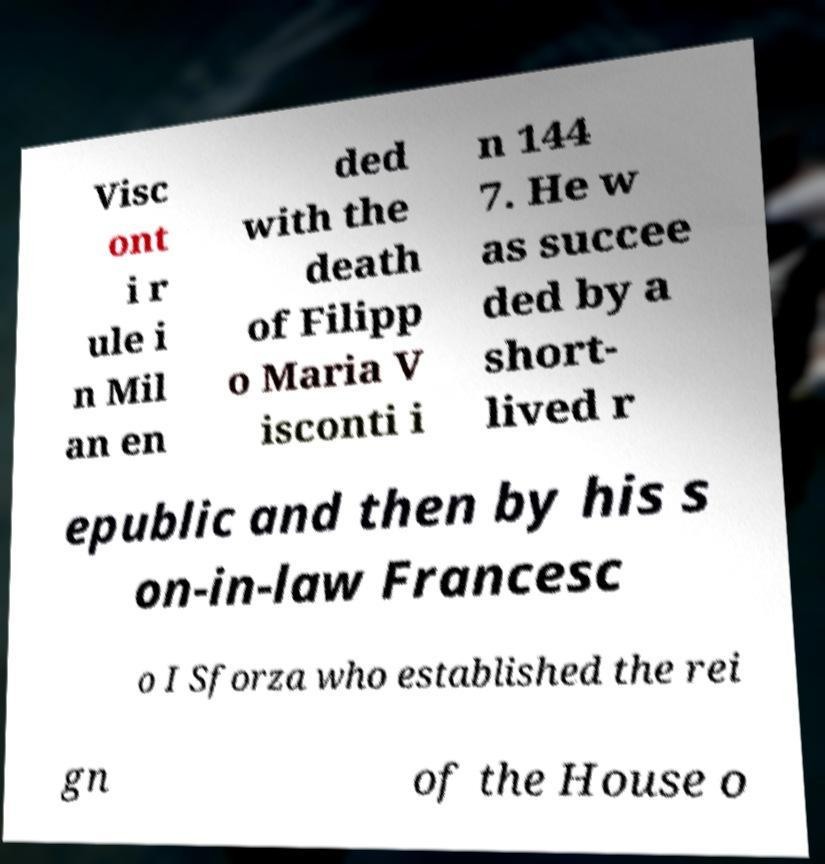Please read and relay the text visible in this image. What does it say? Visc ont i r ule i n Mil an en ded with the death of Filipp o Maria V isconti i n 144 7. He w as succee ded by a short- lived r epublic and then by his s on-in-law Francesc o I Sforza who established the rei gn of the House o 